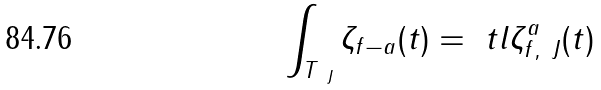<formula> <loc_0><loc_0><loc_500><loc_500>\int _ { T _ { \ J } } \zeta _ { f - a } ( t ) = \ t l { \zeta _ { f , { \ J } } ^ { a } } ( t )</formula> 